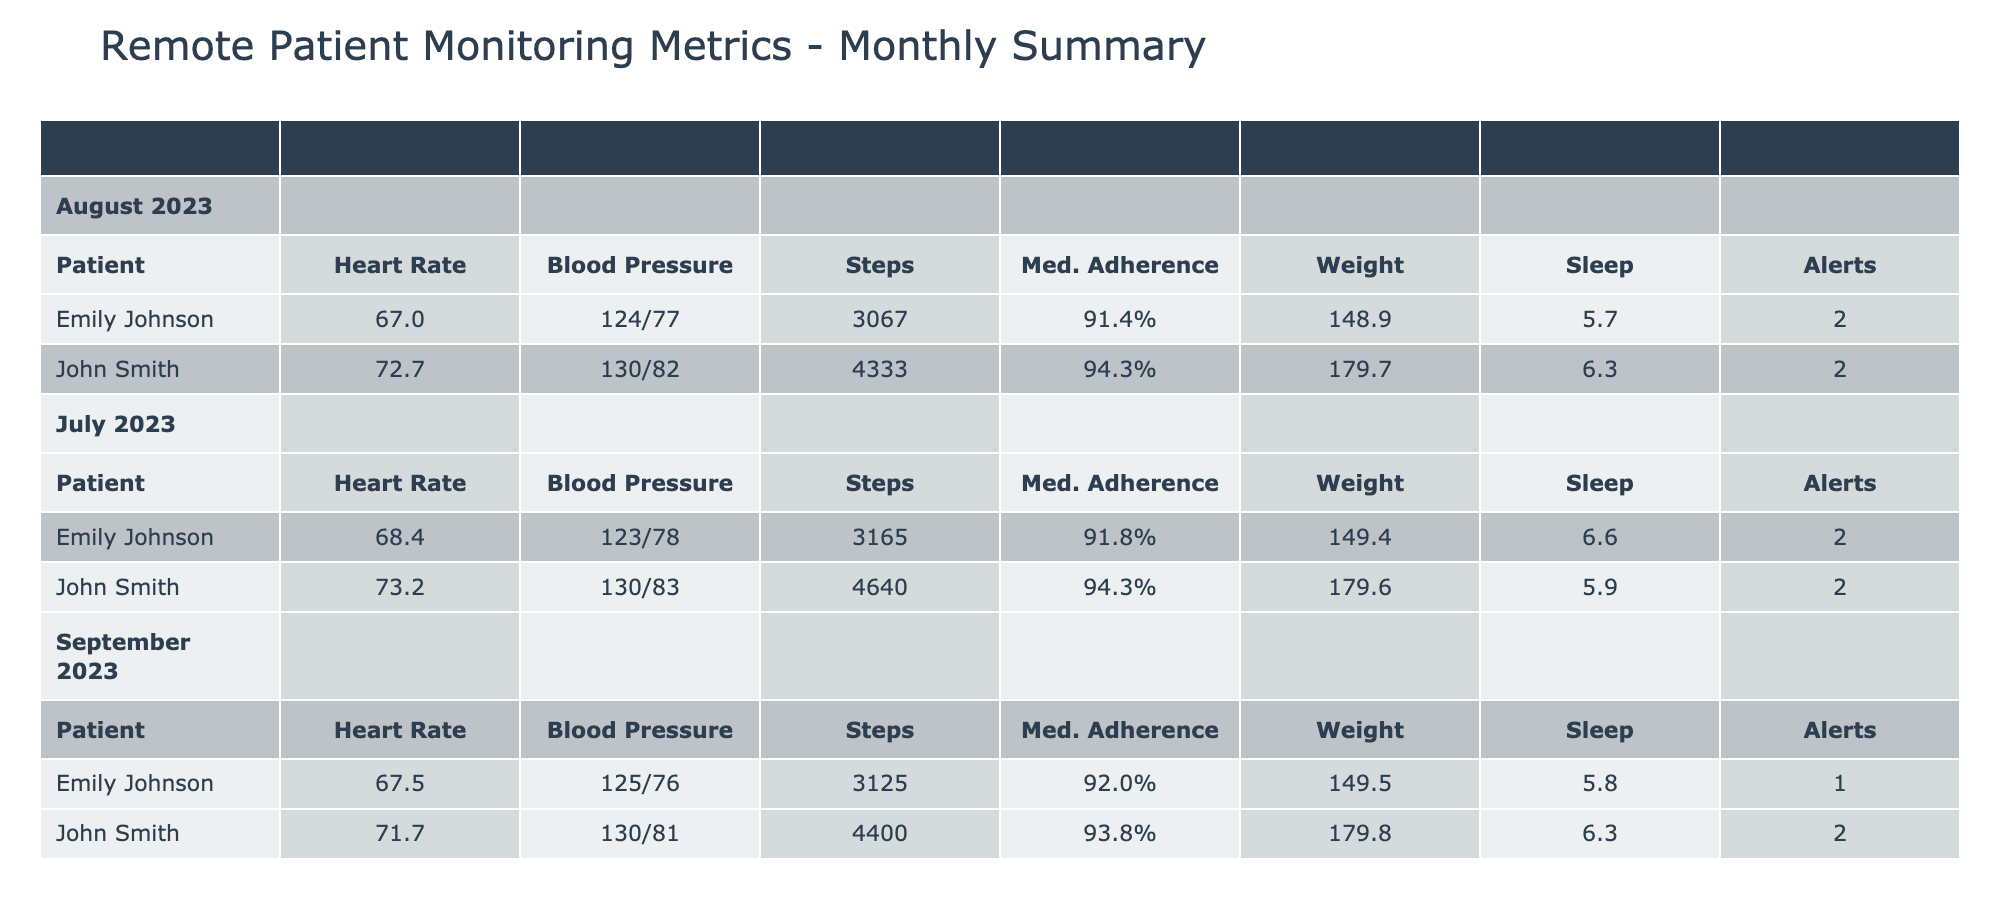What was John Smith's average heart rate over the three months? To find John Smith's average heart rate, I first look at his heart rate values from the table: 72, 70, 75, 71, 74, 73, 76, 75, 74, 72, 71, 69, 70, 73, 72, 75, 74. Next, I sum these values (72 + 70 + 75 + 71 + 74 + 73 + 76 + 75 + 74 + 72 + 71 + 69 + 70 + 73 + 72 + 75 + 74 =  1209) and divide by the number of data points (17): 1209 / 17 ≈ 71.5.
Answer: 71.5 What was Emily Johnson's total medication adherence percentage across the three months? I review Emily Johnson's medication adherence percentages from the table: 90, 88, 94, 89, 92, 97, 96, 95, 92, 91, 90, 96, 92, 93, 91, 94, 90. Adding these numbers (90 + 88 + 94 + 89 + 92 + 97 + 96 + 95 + 92 + 91 + 90 + 96 + 92 + 93 + 91 + 94 + 90 = 1450) gives a total of 1450.
Answer: 1450 Did John Smith ever have an emergency alert during the three-month period? Checking the "Emergency Alerts" column for John Smith, I see that he received alerts on two occasions (1st on July 2 and 2nd on September 1). Since there were alerts, the answer is yes.
Answer: Yes Which month did Emily Johnson have the highest average sleep hours? I compute the average sleep hours for Emily across each month: July (average = 6.5), August (average = 6), and September (average = 5.6). Since July has the highest average sleep (6.5 hours), that month is the answer.
Answer: July What was the change in average weight for John Smith from July to September? First, I calculate John's average weight for July (average = 180 lbs), August (average = 179 lbs), and September (average = 179 lbs). The average weight was the same for August and September. The change in weight from July to September is 179 - 180 = -1 lb.
Answer: -1 lb What percentage of days did Emily have an emergency alert in September? Emily had 4 readings in September and received emergency alerts on September 1 and September 3 (total of 2 alerts). Therefore, the percentage is (2 alerts / 4 total days) * 100 = 50%.
Answer: 50% Was there a day in the three months where both patients walked more than 5000 steps? Looking at the "Steps Walked" column, John walked more than 5000 steps on July 9 (5000 steps) and September 2 (4300 steps), but Emily did not exceed 5000 steps on any of the days recorded. Therefore, the condition is false.
Answer: No What was the combined total number of steps walked by both patients in August? For July totals, I calculate the total steps for both patients: John's August total (as returned in the counts 4200 + 4300 + 4600 + 4400 + 4700 + 4300 + 4000) = 30500 steps and Emily's total (as returned in the counts 3050 + 2950 + 3100 + 3250 + 3000 + 3100 + 2900) = 20500. Summing them gives the total of 30500 + 20500 = 51000 steps.
Answer: 51000 steps What was the highest average blood pressure recorded for either patient? I look at the blood pressure values for both John and Emily from the table. The highest average for John is 132/83 in July, while for Emily it’s 127/78 which is lower than John's. Thus, John's average of 132/83 is the answer.
Answer: 132/83 